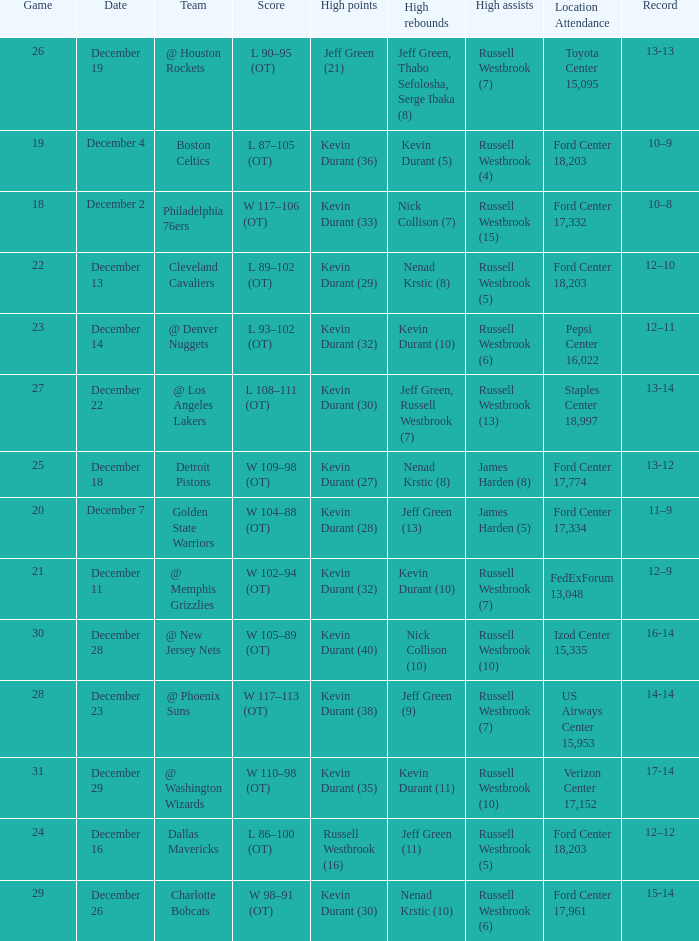Who has high points when toyota center 15,095 is location attendance? Jeff Green (21). Give me the full table as a dictionary. {'header': ['Game', 'Date', 'Team', 'Score', 'High points', 'High rebounds', 'High assists', 'Location Attendance', 'Record'], 'rows': [['26', 'December 19', '@ Houston Rockets', 'L 90–95 (OT)', 'Jeff Green (21)', 'Jeff Green, Thabo Sefolosha, Serge Ibaka (8)', 'Russell Westbrook (7)', 'Toyota Center 15,095', '13-13'], ['19', 'December 4', 'Boston Celtics', 'L 87–105 (OT)', 'Kevin Durant (36)', 'Kevin Durant (5)', 'Russell Westbrook (4)', 'Ford Center 18,203', '10–9'], ['18', 'December 2', 'Philadelphia 76ers', 'W 117–106 (OT)', 'Kevin Durant (33)', 'Nick Collison (7)', 'Russell Westbrook (15)', 'Ford Center 17,332', '10–8'], ['22', 'December 13', 'Cleveland Cavaliers', 'L 89–102 (OT)', 'Kevin Durant (29)', 'Nenad Krstic (8)', 'Russell Westbrook (5)', 'Ford Center 18,203', '12–10'], ['23', 'December 14', '@ Denver Nuggets', 'L 93–102 (OT)', 'Kevin Durant (32)', 'Kevin Durant (10)', 'Russell Westbrook (6)', 'Pepsi Center 16,022', '12–11'], ['27', 'December 22', '@ Los Angeles Lakers', 'L 108–111 (OT)', 'Kevin Durant (30)', 'Jeff Green, Russell Westbrook (7)', 'Russell Westbrook (13)', 'Staples Center 18,997', '13-14'], ['25', 'December 18', 'Detroit Pistons', 'W 109–98 (OT)', 'Kevin Durant (27)', 'Nenad Krstic (8)', 'James Harden (8)', 'Ford Center 17,774', '13-12'], ['20', 'December 7', 'Golden State Warriors', 'W 104–88 (OT)', 'Kevin Durant (28)', 'Jeff Green (13)', 'James Harden (5)', 'Ford Center 17,334', '11–9'], ['21', 'December 11', '@ Memphis Grizzlies', 'W 102–94 (OT)', 'Kevin Durant (32)', 'Kevin Durant (10)', 'Russell Westbrook (7)', 'FedExForum 13,048', '12–9'], ['30', 'December 28', '@ New Jersey Nets', 'W 105–89 (OT)', 'Kevin Durant (40)', 'Nick Collison (10)', 'Russell Westbrook (10)', 'Izod Center 15,335', '16-14'], ['28', 'December 23', '@ Phoenix Suns', 'W 117–113 (OT)', 'Kevin Durant (38)', 'Jeff Green (9)', 'Russell Westbrook (7)', 'US Airways Center 15,953', '14-14'], ['31', 'December 29', '@ Washington Wizards', 'W 110–98 (OT)', 'Kevin Durant (35)', 'Kevin Durant (11)', 'Russell Westbrook (10)', 'Verizon Center 17,152', '17-14'], ['24', 'December 16', 'Dallas Mavericks', 'L 86–100 (OT)', 'Russell Westbrook (16)', 'Jeff Green (11)', 'Russell Westbrook (5)', 'Ford Center 18,203', '12–12'], ['29', 'December 26', 'Charlotte Bobcats', 'W 98–91 (OT)', 'Kevin Durant (30)', 'Nenad Krstic (10)', 'Russell Westbrook (6)', 'Ford Center 17,961', '15-14']]} 